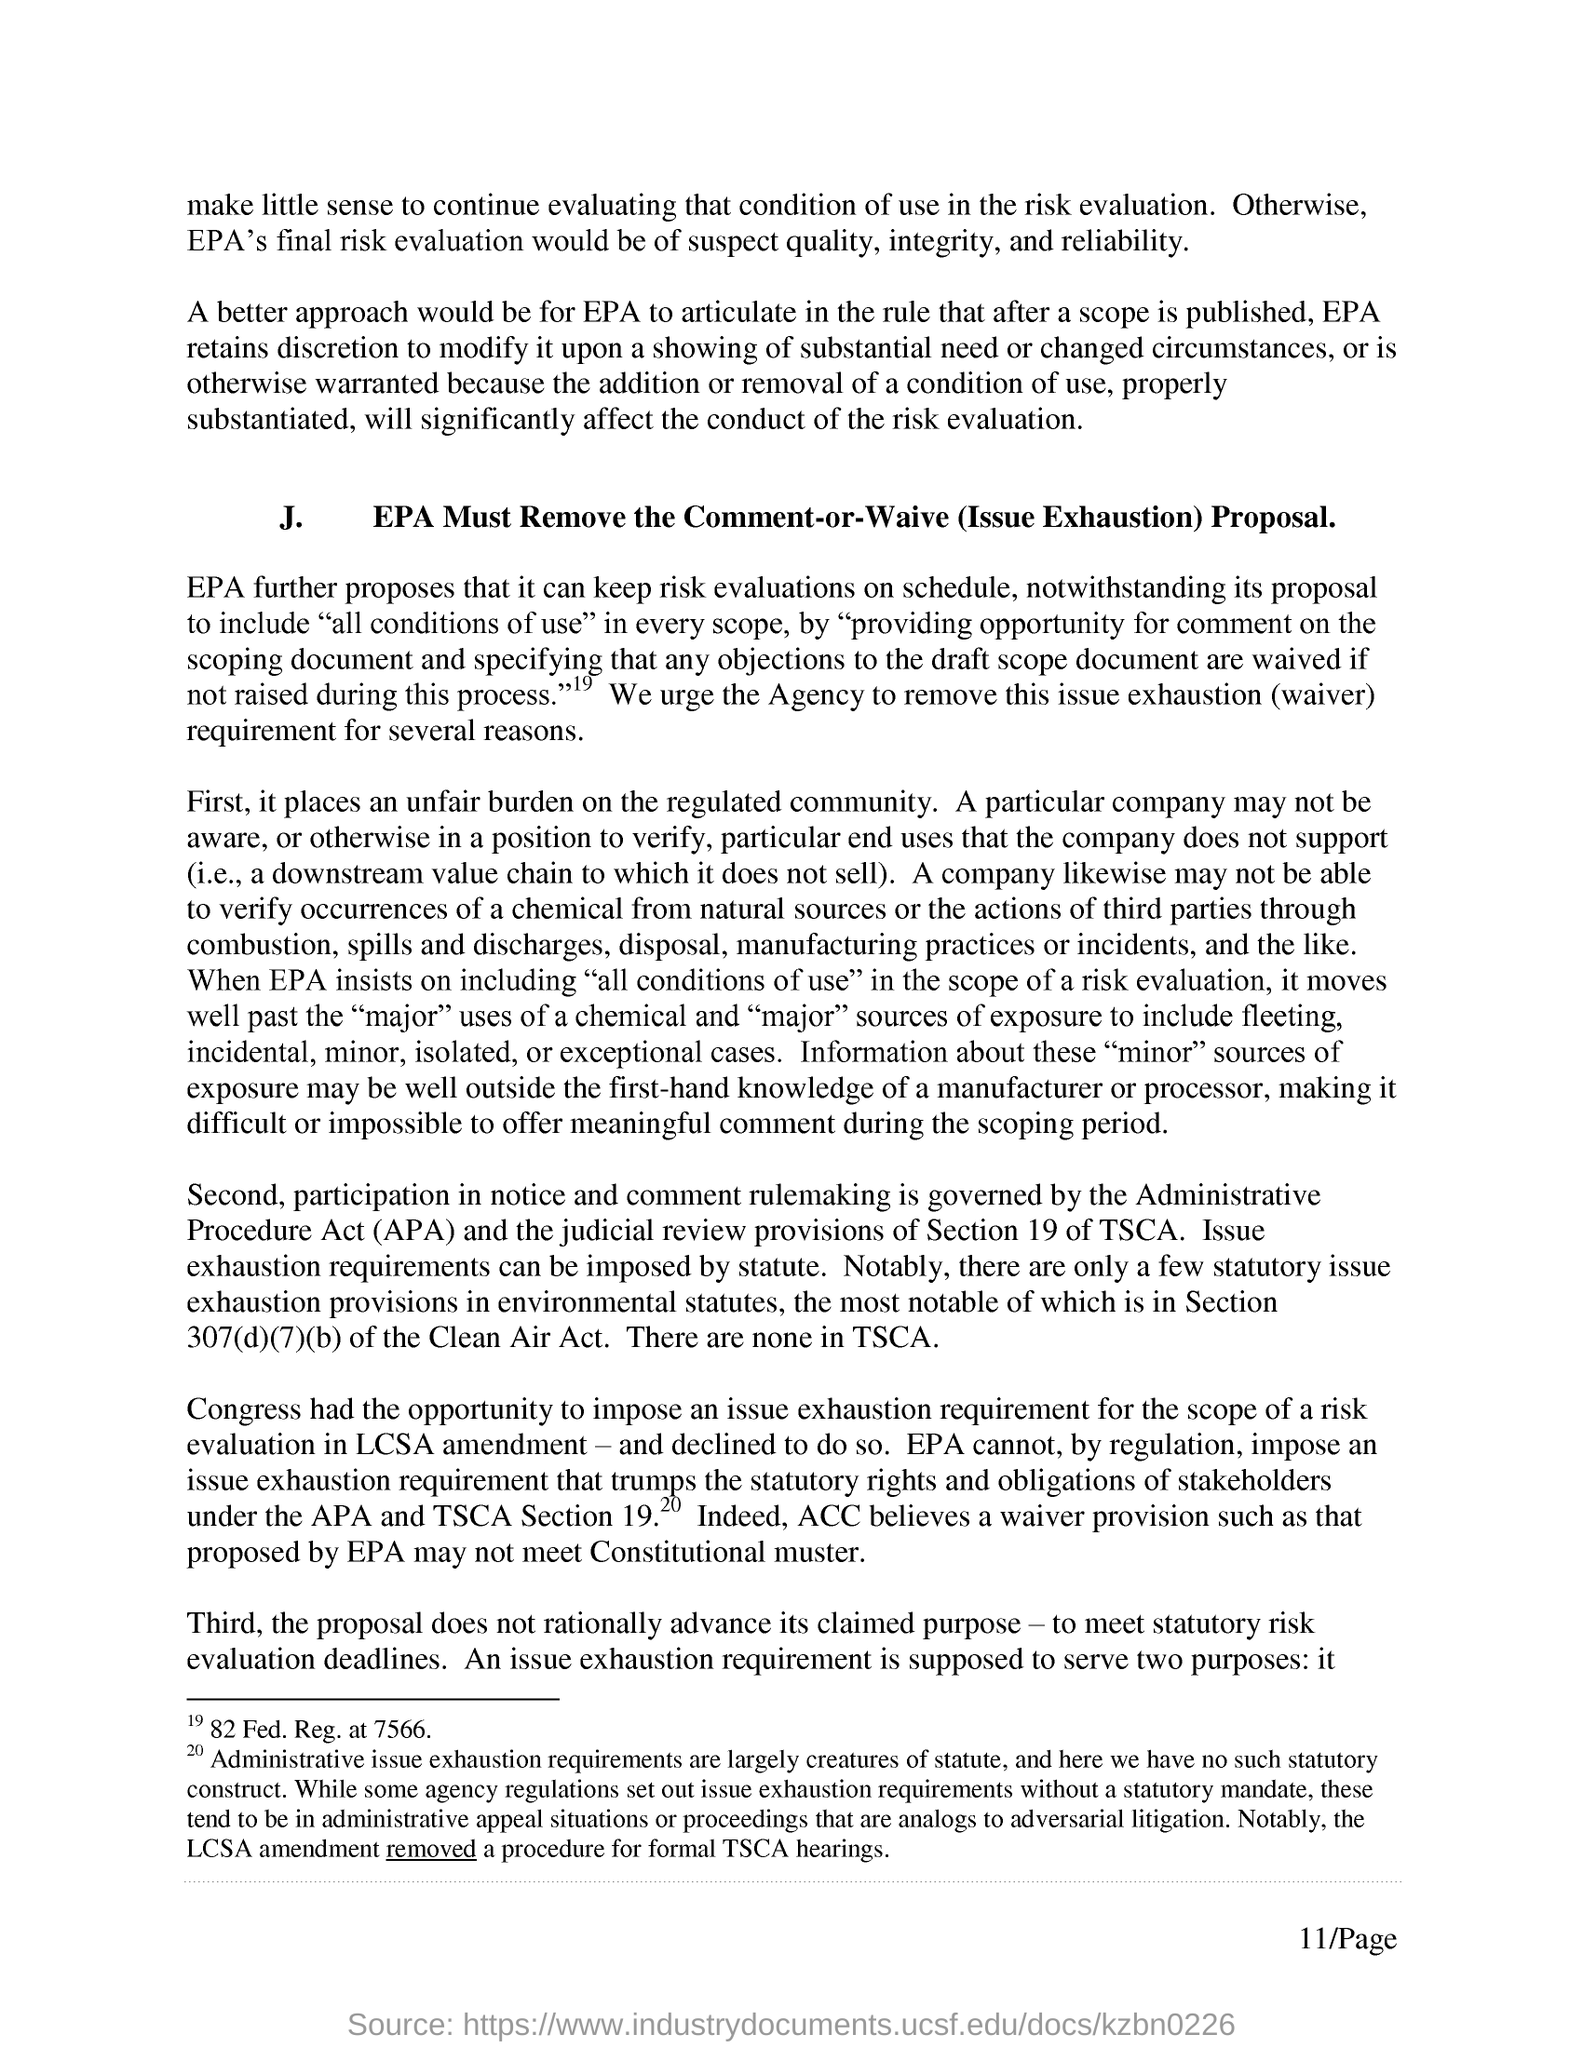Outline some significant characteristics in this image. The section of the Toxic Substances Control Act (TSCA) that deals with judicial review provisions is Section 19. APA stands for the Administrative Procedure Act, which is a law that sets out the procedures that government agencies must follow when making decisions and issuing regulations. The section of environmental statutes that contains provisions for issue exhaustion is Section 307(d)(7)(b). Based on the EPA's final risk evaluation, there are concerns about the quality, integrity, and reliability of the data. The Clean Air Act, specifically section 307(d)(7)(b), is the act that applies. 